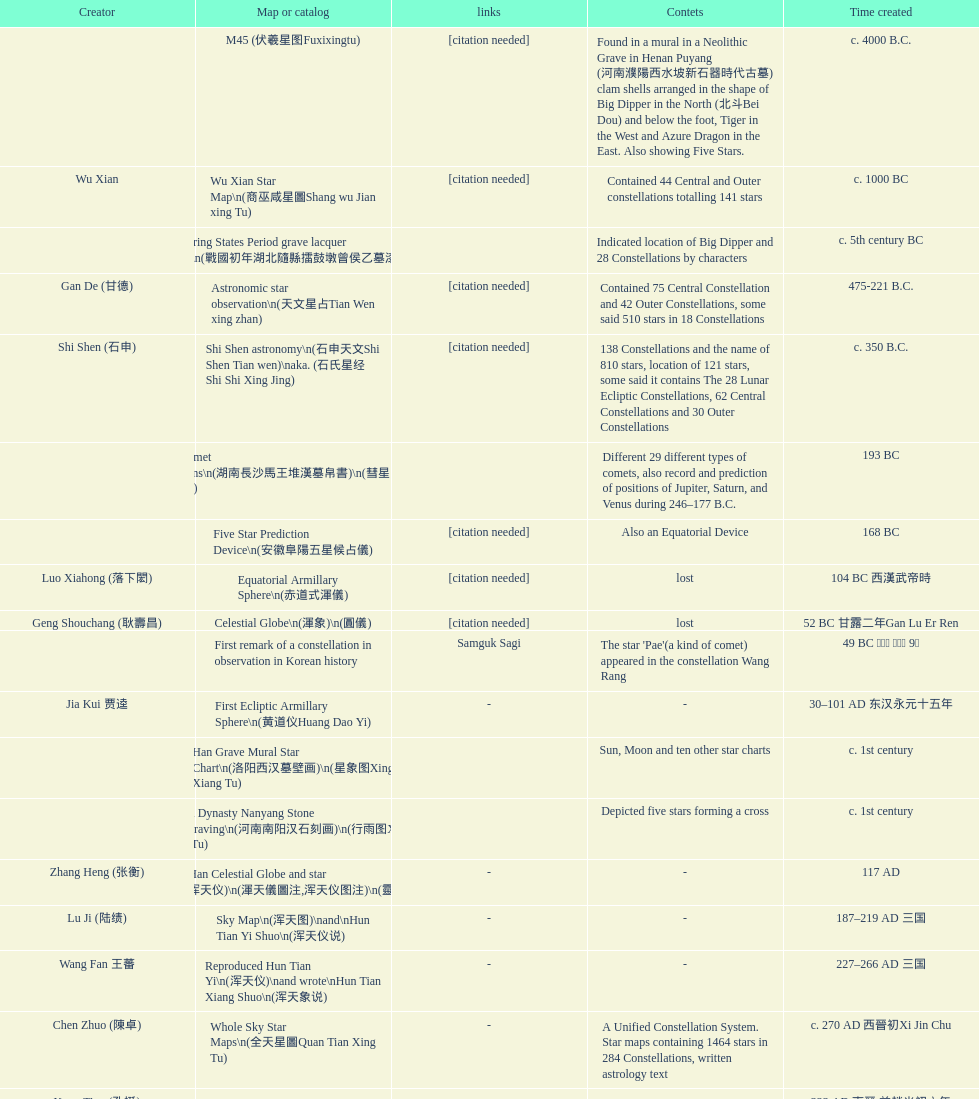Would you mind parsing the complete table? {'header': ['Creator', 'Map or catalog', 'links', 'Contets', 'Time created'], 'rows': [['', 'M45 (伏羲星图Fuxixingtu)', '[citation needed]', 'Found in a mural in a Neolithic Grave in Henan Puyang (河南濮陽西水坡新石器時代古墓) clam shells arranged in the shape of Big Dipper in the North (北斗Bei Dou) and below the foot, Tiger in the West and Azure Dragon in the East. Also showing Five Stars.', 'c. 4000 B.C.'], ['Wu Xian', 'Wu Xian Star Map\\n(商巫咸星圖Shang wu Jian xing Tu)', '[citation needed]', 'Contained 44 Central and Outer constellations totalling 141 stars', 'c. 1000 BC'], ['', 'Warring States Period grave lacquer box\\n(戰國初年湖北隨縣擂鼓墩曾侯乙墓漆箱)', '', 'Indicated location of Big Dipper and 28 Constellations by characters', 'c. 5th century BC'], ['Gan De (甘德)', 'Astronomic star observation\\n(天文星占Tian Wen xing zhan)', '[citation needed]', 'Contained 75 Central Constellation and 42 Outer Constellations, some said 510 stars in 18 Constellations', '475-221 B.C.'], ['Shi Shen (石申)', 'Shi Shen astronomy\\n(石申天文Shi Shen Tian wen)\\naka. (石氏星经 Shi Shi Xing Jing)', '[citation needed]', '138 Constellations and the name of 810 stars, location of 121 stars, some said it contains The 28 Lunar Ecliptic Constellations, 62 Central Constellations and 30 Outer Constellations', 'c. 350 B.C.'], ['', 'Han Comet Diagrams\\n(湖南長沙馬王堆漢墓帛書)\\n(彗星圖Meng xing Tu)', '', 'Different 29 different types of comets, also record and prediction of positions of Jupiter, Saturn, and Venus during 246–177 B.C.', '193 BC'], ['', 'Five Star Prediction Device\\n(安徽阜陽五星候占儀)', '[citation needed]', 'Also an Equatorial Device', '168 BC'], ['Luo Xiahong (落下閎)', 'Equatorial Armillary Sphere\\n(赤道式渾儀)', '[citation needed]', 'lost', '104 BC 西漢武帝時'], ['Geng Shouchang (耿壽昌)', 'Celestial Globe\\n(渾象)\\n(圓儀)', '[citation needed]', 'lost', '52 BC 甘露二年Gan Lu Er Ren'], ['', 'First remark of a constellation in observation in Korean history', 'Samguk Sagi', "The star 'Pae'(a kind of comet) appeared in the constellation Wang Rang", '49 BC 혁거세 거서간 9년'], ['Jia Kui 贾逵', 'First Ecliptic Armillary Sphere\\n(黄道仪Huang Dao Yi)', '-', '-', '30–101 AD 东汉永元十五年'], ['', 'Han Grave Mural Star Chart\\n(洛阳西汉墓壁画)\\n(星象图Xing Xiang Tu)', '', 'Sun, Moon and ten other star charts', 'c. 1st century'], ['', 'Han Dynasty Nanyang Stone Engraving\\n(河南南阳汉石刻画)\\n(行雨图Xing Yu Tu)', '', 'Depicted five stars forming a cross', 'c. 1st century'], ['Zhang Heng (张衡)', 'Eastern Han Celestial Globe and star maps\\n(浑天仪)\\n(渾天儀圖注,浑天仪图注)\\n(靈憲,灵宪)', '-', '-', '117 AD'], ['Lu Ji (陆绩)', 'Sky Map\\n(浑天图)\\nand\\nHun Tian Yi Shuo\\n(浑天仪说)', '-', '-', '187–219 AD 三国'], ['Wang Fan 王蕃', 'Reproduced Hun Tian Yi\\n(浑天仪)\\nand wrote\\nHun Tian Xiang Shuo\\n(浑天象说)', '-', '-', '227–266 AD 三国'], ['Chen Zhuo (陳卓)', 'Whole Sky Star Maps\\n(全天星圖Quan Tian Xing Tu)', '-', 'A Unified Constellation System. Star maps containing 1464 stars in 284 Constellations, written astrology text', 'c. 270 AD 西晉初Xi Jin Chu'], ['Kong Ting (孔挺)', 'Equatorial Armillary Sphere\\n(渾儀Hun Xi)', '-', 'level being used in this kind of device', '323 AD 東晉 前趙光初六年'], ['Hu Lan (斛蘭)', 'Northern Wei Period Iron Armillary Sphere\\n(鐵渾儀)', '', '-', 'Bei Wei\\plevel being used in this kind of device'], ['Qian Lezhi (錢樂之)', 'Southern Dynasties Period Whole Sky Planetarium\\n(渾天象Hun Tian Xiang)', '-', 'used red, black and white to differentiate stars from different star maps from Shi Shen, Gan De and Wu Xian 甘, 石, 巫三家星', '443 AD 南朝劉宋元嘉年間'], ['', 'Northern Wei Grave Dome Star Map\\n(河南洛陽北魏墓頂星圖)', '', 'about 300 stars, including the Big Dipper, some stars are linked by straight lines to form constellation. The Milky Way is also shown.', '526 AD 北魏孝昌二年'], ['Geng Xun (耿詢)', 'Water-powered Planetarium\\n(水力渾天儀)', '-', '-', 'c. 7th century 隋初Sui Chu'], ['Yu Jicai (庾季才) and Zhou Fen (周墳)', 'Lingtai Miyuan\\n(靈台秘苑)', '-', 'incorporated star maps from different sources', '604 AD 隋Sui'], ['Li Chunfeng 李淳風', 'Tang Dynasty Whole Sky Ecliptic Armillary Sphere\\n(渾天黃道儀)', '-', 'including Elliptic and Moon orbit, in addition to old equatorial design', '667 AD 貞觀七年'], ['Dun Huang', 'The Dunhuang star map\\n(燉煌)', '', '1,585 stars grouped into 257 clusters or "asterisms"', '705–710 AD'], ['', 'Turfan Tomb Star Mural\\n(新疆吐鲁番阿斯塔那天文壁画)', '', '28 Constellations, Milkyway and Five Stars', '250–799 AD 唐'], ['', 'Picture of Fuxi and Nüwa 新疆阿斯達那唐墓伏羲Fu Xi 女媧NV Wa像Xiang', 'Image:Nuva fuxi.gif', 'Picture of Fuxi and Nuwa together with some constellations', 'Tang Dynasty'], ['Yixing Monk 一行和尚 (张遂)Zhang Sui and Liang Lingzan 梁令瓚', 'Tang Dynasty Armillary Sphere\\n(唐代渾儀Tang Dai Hun Xi)\\n(黃道遊儀Huang dao you xi)', '', 'based on Han Dynasty Celestial Globe, recalibrated locations of 150 stars, determined that stars are moving', '683–727 AD'], ['Yixing Priest 一行和尚 (张遂)\\pZhang Sui\\p683–727 AD', 'Tang Dynasty Indian Horoscope Chart\\n(梵天火羅九曜)', '', '', 'simple diagrams of the 28 Constellation'], ['', 'Kitora Kofun 法隆寺FaLong Si\u3000キトラ古墳 in Japan', '', 'Detailed whole sky map', 'c. late 7th century – early 8th century'], ['Gautama Siddha', 'Treatise on Astrology of the Kaiyuan Era\\n(開元占経,开元占经Kai Yuan zhang Jing)', '-', 'Collection of the three old star charts from Shi Shen, Gan De and Wu Xian. One of the most renowned collection recognized academically.', '713 AD –'], ['', 'Big Dipper\\n(山東嘉祥武梁寺石刻北斗星)', '', 'showing stars in Big Dipper', '–'], ['', 'Prajvalonisa Vjrabhairava Padvinasa-sri-dharani Scroll found in Japan 熾盛光佛頂大威德銷災吉祥陀羅尼經卷首扉畫', '-', 'Chinese 28 Constellations and Western Zodiac', '972 AD 北宋開寶五年'], ['', 'Tangut Khara-Khoto (The Black City) Star Map 西夏黑水城星圖', '-', 'A typical Qian Lezhi Style Star Map', '940 AD'], ['', 'Star Chart 五代吳越文穆王前元瓘墓石刻星象圖', '', '-', '941–960 AD'], ['', 'Ancient Star Map 先天图 by 陈抟Chen Tuan', 'Lost', 'Perhaps based on studying of Puyong Ancient Star Map', 'c. 11th Chen Tuan 宋Song'], ['Han Xianfu 韓顯符', 'Song Dynasty Bronze Armillary Sphere 北宋至道銅渾儀', '-', 'Similar to the Simplified Armillary by Kong Ting 孔挺, 晁崇 Chao Chong, 斛蘭 Hu Lan', '1006 AD 宋道元年十二月'], ['Shu Yijian 舒易簡, Yu Yuan 于渊, Zhou Cong 周琮', 'Song Dynasty Bronze Armillary Sphere 北宋天文院黄道渾儀', '-', 'Similar to the Armillary by Tang Dynasty Liang Lingzan 梁令瓚 and Yi Xing 一行', '宋皇祐年中'], ['Shen Kuo 沈括 and Huangfu Yu 皇甫愈', 'Song Dynasty Armillary Sphere 北宋簡化渾儀', '-', 'Simplied version of Tang Dynasty Device, removed the rarely used moon orbit.', '1089 AD 熙寧七年'], ['Su Song 蘇頌', 'Five Star Charts (新儀象法要)', 'Image:Su Song Star Map 1.JPG\\nImage:Su Song Star Map 2.JPG', '1464 stars grouped into 283 asterisms', '1094 AD'], ['Su Song 蘇頌 and Han Gonglian 韩公廉', 'Song Dynasty Water-powered Planetarium 宋代 水运仪象台', '', '-', 'c. 11th century'], ['', 'Liao Dynasty Tomb Dome Star Map 遼宣化张世卿墓頂星圖', '', 'shown both the Chinese 28 Constellation encircled by Babylonian Zodiac', '1116 AD 遼天庆六年'], ['', "Star Map in a woman's grave (江西德安 南宋周氏墓星相图)", '', 'Milky Way and 57 other stars.', '1127–1279 AD'], ['Huang Shang (黃裳)', 'Hun Tian Yi Tong Xing Xiang Quan Tu, Suzhou Star Chart (蘇州石刻天文圖),淳祐天文図', '', '1434 Stars grouped into 280 Asterisms in Northern Sky map', 'created in 1193, etched to stone in 1247 by Wang Zhi Yuan 王致遠'], ['Guo Shou Jing 郭守敬', 'Yuan Dynasty Simplified Armillary Sphere 元代簡儀', '', 'Further simplied version of Song Dynasty Device', '1276–1279'], ['', 'Japanese Star Chart 格子月進図', '', 'Similar to Su Song Star Chart, original burned in air raids during World War II, only pictures left. Reprinted in 1984 by 佐佐木英治', '1324'], ['', '天象列次分野之図(Cheonsang Yeolcha Bunyajido)', '', 'Korean versions of Star Map in Stone. It was made in Chosun Dynasty and the constellation names were written in Chinese letter. The constellations as this was found in Japanese later. Contained 1,464 stars.', '1395'], ['', 'Japanese Star Chart 瀧谷寺 天之図', '', '-', 'c. 14th or 15th centuries 室町中期以前'], ['', "Korean King Sejong's Armillary sphere", '', '-', '1433'], ['Mao Kun 茅坤', 'Star Chart', 'zh:郑和航海图', 'Polaris compared with Southern Cross and Alpha Centauri', 'c. 1422'], ['', 'Korean Tomb', '', 'Big Dipper', 'c. late 14th century'], ['', 'Ming Ancient Star Chart 北京隆福寺(古星圖)', '', '1420 Stars, possibly based on old star maps from Tang Dynasty', 'c. 1453 明代'], ['', 'Chanshu Star Chart (明常熟石刻天文圖)', '-', 'Based on Suzhou Star Chart, Northern Sky observed at 36.8 degrees North Latitude, 1466 stars grouped into 284 asterism', '1506'], ['Matteo Ricci 利玛窦Li Ma Dou, recorded by Li Zhizao 李之藻', 'Ming Dynasty Star Map (渾蓋通憲圖說)', '', '-', 'c. 1550'], ['Xiao Yun Cong 萧云从', 'Tian Wun Tu (天问图)', '', 'Contained mapping of 12 constellations and 12 animals', 'c. 1600'], ['by 尹真人高第弟子 published by 余永宁', 'Zhou Tian Xuan Ji Tu (周天璇玑图) and He He Si Xiang Tu (和合四象圖) in Xing Ming Gui Zhi (性命圭旨)', '', 'Drawings of Armillary Sphere and four Chinese Celestial Animals with some notes. Related to Taoism.', '1615'], ['', 'Korean Astronomy Book "Selected and Systematized Astronomy Notes" 天文類抄', '', 'Contained some star maps', '1623~1649'], ['Xu Guang ci 徐光啟 and Adam Schall von Bell Tang Ruo Wang湯若望', 'Ming Dynasty General Star Map (赤道南北兩總星圖)', '', '-', '1634'], ['Xu Guang ci 徐光啟', 'Ming Dynasty diagrams of Armillary spheres and Celestial Globes', '', '-', 'c. 1699'], ['', 'Ming Dynasty Planetarium Machine (渾象 Hui Xiang)', '', 'Ecliptic, Equator, and dividers of 28 constellation', 'c. 17th century'], ['', 'Copper Plate Star Map stored in Korea', '', '-', '1652 順治九年shun zi jiu nian'], ['Harumi Shibukawa 渋川春海Bu Chuan Chun Mei(保井春海Bao Jing Chun Mei)', 'Japanese Edo period Star Chart 天象列次之図 based on 天象列次分野之図 from Korean', '', '-', '1670 寛文十年'], ['Ferdinand Verbiest 南懷仁', 'The Celestial Globe 清康熙 天體儀', '', '1876 stars grouped into 282 asterisms', '1673'], ['Japanese painter', 'Picture depicted Song Dynasty fictional astronomer (呉用 Wu Yong) with a Celestial Globe (天體儀)', 'File:Chinese astronomer 1675.jpg', 'showing top portion of a Celestial Globe', '1675'], ['Harumi Shibukawa 渋川春海BuJingChun Mei (保井春海Bao JingChunMei)', 'Japanese Edo period Star Chart 天文分野之図', '', '-', '1677 延宝五年'], ['', 'Korean star map in stone', '', '-', '1687'], ['井口常範', 'Japanese Edo period Star Chart 天文図解', '-', '-', '1689 元禄2年'], ['苗村丈伯Mao Chun Zhang Bo', 'Japanese Edo period Star Chart 古暦便覧備考', '-', '-', '1692 元禄5年'], ['Harumi Yasui written in Chinese', 'Japanese star chart', '', 'A Japanese star chart of 1699 showing lunar stations', '1699 AD'], ['(渋川昔尹She Chuan Xi Yin) (保井昔尹Bao Jing Xi Yin)', 'Japanese Edo period Star Chart 天文成象Tian Wen Cheng xiang', '', 'including Stars from Wu Shien (44 Constellation, 144 stars) in yellow; Gan De (118 Constellations, 511 stars) in black; Shi Shen (138 Constellations, 810 stars) in red and Harumi Shibukawa (61 Constellations, 308 stars) in blue;', '1699 元禄十二年'], ['', 'Japanese Star Chart 改正天文図説', '', 'Included stars from Harumi Shibukawa', 'unknown'], ['', 'Korean Star Map Stone', '', '-', 'c. 17th century'], ['', 'Korean Star Map', '', '-', 'c. 17th century'], ['', 'Ceramic Ink Sink Cover', '', 'Showing Big Dipper', 'c. 17th century'], ['Italian Missionary Philippus Maria Grimardi 閔明我 (1639~1712)', 'Korean Star Map Cube 方星圖', '', '-', 'c. early 18th century'], ['You Zi liu 游子六', 'Star Chart preserved in Japan based on a book from China 天経或問', '', 'A Northern Sky Chart in Chinese', '1730 AD 江戸時代 享保15年'], ['', 'Star Chart 清蒙文石刻(欽天監繪製天文圖) in Mongolia', '', '1550 stars grouped into 270 starisms.', '1727–1732 AD'], ['', 'Korean Star Maps, North and South to the Eclliptic 黃道南北恒星圖', '', '-', '1742'], ['入江脩敬Ru Jiang YOu Jing', 'Japanese Edo period Star Chart 天経或問註解図巻\u3000下', '-', '-', '1750 寛延3年'], ['Dai Zhen 戴震', 'Reproduction of an ancient device 璇璣玉衡', 'Could be similar to', 'based on ancient record and his own interpretation', '1723–1777 AD'], ['', 'Rock Star Chart 清代天文石', '', 'A Star Chart and general Astronomy Text', 'c. 18th century'], ['', 'Korean Complete Star Map (渾天全圖)', '', '-', 'c. 18th century'], ['Yun Lu 允禄 and Ignatius Kogler 戴进贤Dai Jin Xian 戴進賢, a German', 'Qing Dynasty Star Catalog (儀象考成,仪象考成)恒星表 and Star Map 黄道南北両星総図', '', '300 Constellations and 3083 Stars. Referenced Star Catalogue published by John Flamsteed', 'Device made in 1744, book completed in 1757 清乾隆年间'], ['', 'Jingban Tianwen Quantu by Ma Junliang 马俊良', '', 'mapping nations to the sky', '1780–90 AD'], ['Yan Qiao Shan Bing Heng 岩橋善兵衛', 'Japanese Edo period Illustration of a Star Measuring Device 平天儀図解', 'The device could be similar to', '-', '1802 Xiang He Er Nian 享和二年'], ['Xu Choujun 徐朝俊', 'North Sky Map 清嘉庆年间Huang Dao Zhong Xi He Tu(黄道中西合图)', '', 'More than 1000 stars and the 28 consellation', '1807 AD'], ['Chao Ye Bei Shui 朝野北水', 'Japanese Edo period Star Chart 天象総星之図', '-', '-', '1814 文化十一年'], ['田中政均', 'Japanese Edo period Star Chart 新制天球星象記', '-', '-', '1815 文化十二年'], ['坂部廣胖', 'Japanese Edo period Star Chart 天球図', '-', '-', '1816 文化十三年'], ['John Reeves esq', 'Chinese Star map', '', 'Printed map showing Chinese names of stars and constellations', '1819 AD'], ['佐藤祐之', 'Japanese Edo period Star Chart 昊天図説詳解', '-', '-', '1824 文政七年'], ['小島好謙 and 鈴木世孝', 'Japanese Edo period Star Chart 星図歩天歌', '-', '-', '1824 文政七年'], ['鈴木世孝', 'Japanese Edo period Star Chart', '-', '-', '1824 文政七年'], ['長久保赤水', 'Japanese Edo period Star Chart 天象管鈔 天体図 (天文星象図解)', '', '-', '1824 文政七年'], ['足立信順Zhu Li Xin Shun', 'Japanese Edo period Star Measuring Device 中星儀', '-', '-', '1824 文政七年'], ['桜田虎門', 'Japanese Star Map 天象一覧図 in Kanji', '', 'Printed map showing Chinese names of stars and constellations', '1824 AD 文政７年'], ['', 'Korean Star Map 天象列次分野之図 in Kanji', '[18]', 'Printed map showing Chinese names of stars and constellations', 'c. 19th century'], ['', 'Korean Star Map', '', '-', 'c. 19th century, late Choson Period'], ['', 'Korean Star maps: Star Map South to the Ecliptic 黃道南恒星圖 and Star Map South to the Ecliptic 黃道北恒星圖', '', 'Perhaps influenced by Adam Schall von Bell Tang Ruo wang 湯若望 (1591–1666) and P. Ignatius Koegler 戴進賢 (1680–1748)', 'c. 19th century'], ['', 'Korean Complete map of the celestial sphere (渾天全圖)', '', '-', 'c. 19th century'], ['', 'Korean Book of Stars 經星', '', 'Several star maps', 'c. 19th century'], ['石坂常堅', 'Japanese Edo period Star Chart 方円星図,方圓星図 and 増補分度星図方図', '-', '-', '1826b文政9年'], ['伊能忠誨', 'Japanese Star Chart', '-', '-', 'c. 19th century'], ['古筆源了材', 'Japanese Edo period Star Chart 天球図説', '-', '-', '1835 天保6年'], ['', 'Qing Dynasty Star Catalog (儀象考成續編)星表', '', 'Appendix to Yi Xian Kao Cheng, listed 3240 stars (added 163, removed 6)', '1844'], ['', 'Stars map (恒星赤道経緯度図)stored in Japan', '-', '-', '1844 道光24年 or 1848'], ['藤岡有貞', 'Japanese Edo period Star Chart 経緯簡儀用法', '-', '-', '1845 弘化２年'], ['高塚福昌, 阿部比輔, 上条景弘', 'Japanese Edo period Star Chart 分野星図', '-', '-', '1849 嘉永2年'], ['遠藤盛俊', 'Japanese Late Edo period Star Chart 天文図屏風', '-', '-', 'late Edo Period 江戸時代後期'], ['三浦梅園', 'Japanese Star Chart 天体図', '-', '-', '-'], ['高橋景保', 'Japanese Star Chart 梅園星図', '', '-', '-'], ['李俊養', 'Korean Book of New Song of the Sky Pacer 新法步天歌', '', 'Star maps and a revised version of the Song of Sky Pacer', '1862'], ['', 'Stars South of Equator, Stars North of Equator (赤道南恆星圖,赤道北恆星圖)', '', 'Similar to Ming Dynasty General Star Map', '1875～1908 清末光緒年間'], ['', 'Fuxi 64 gua 28 xu wood carving 天水市卦台山伏羲六十四卦二十八宿全图', '-', '-', 'modern'], ['', 'Korean Map of Heaven and Earth 天地圖', '', '28 Constellations and geographic map', 'c. 19th century'], ['', 'Korean version of 28 Constellation 列宿圖', '', '28 Constellations, some named differently from their Chinese counterparts', 'c. 19th century'], ['朴?', 'Korean Star Chart 渾天図', '-', '-', '-'], ['', 'Star Chart in a Dao Temple 玉皇山道觀星圖', '-', '-', '1940 AD'], ['Yi Shi Tong 伊世同', 'Simplified Chinese and Western Star Map', '', 'Star Map showing Chinese Xingquan and Western Constellation boundaries', 'Aug. 1963'], ['Yu Xi Dao Ren 玉溪道人', 'Sky Map', '', 'Star Map with captions', '1987'], ['Sun Xiaochun and Jacob Kistemaker', 'The Chinese Sky during the Han Constellating Stars and Society', '', 'An attempt to recreate night sky seen by Chinese 2000 years ago', '1997 AD'], ['', 'Star map', '', 'An attempt by a Japanese to reconstruct the night sky for a historical event around 235 AD 秋風五丈原', 'Recent'], ['', 'Star maps', '', 'Chinese 28 Constellation with Chinese and Japanese captions', 'Recent'], ['', 'SinoSky Beta 2.0', '', 'A computer program capable of showing Chinese Xingguans alongside with western constellations, lists about 700 stars with Chinese names.', '2002'], ['', 'AEEA Star maps', '', 'Good reconstruction and explanation of Chinese constellations', 'Modern'], ['', 'Wikipedia Star maps', 'zh:華蓋星', '-', 'Modern'], ['', '28 Constellations, big dipper and 4 symbols Star map', '', '-', 'Modern'], ['', 'Collection of printed star maps', '', '-', 'Modern'], ['-', '28 Xu Star map and catalog', '', 'Stars around ecliptic', 'Modern'], ['Jeong, Tae-Min(jtm71)/Chuang_Siau_Chin', 'HNSKY Korean/Chinese Supplement', '', 'Korean supplement is based on CheonSangYeulChaBunYaZiDo (B.C.100 ~ A.D.100)', 'Modern'], ['G.S.K. Lee; Jeong, Tae-Min(jtm71); Yu-Pu Wang (evanzxcv)', 'Stellarium Chinese and Korean Sky Culture', '', 'Major Xingguans and Star names', 'Modern'], ['Xi Chun Sheng Chong Hui\\p2005 redrawn, original unknown', '修真內外火侯全圖 Huo Hou Tu', '', '', 'illustrations of Milkyway and star maps, Chinese constellations in Taoism view'], ['坐井★观星Zuo Jing Guan Xing', 'Star Map with illustrations for Xingguans', '', 'illustrations for cylindrical and circular polar maps', 'Modern'], ['', 'Sky in Google Earth KML', '', 'Attempts to show Chinese Star Maps on Google Earth', 'Modern']]} Which was the first chinese star map known to have been created? M45 (伏羲星图Fuxixingtu). 